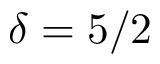<formula> <loc_0><loc_0><loc_500><loc_500>\delta = 5 / 2</formula> 